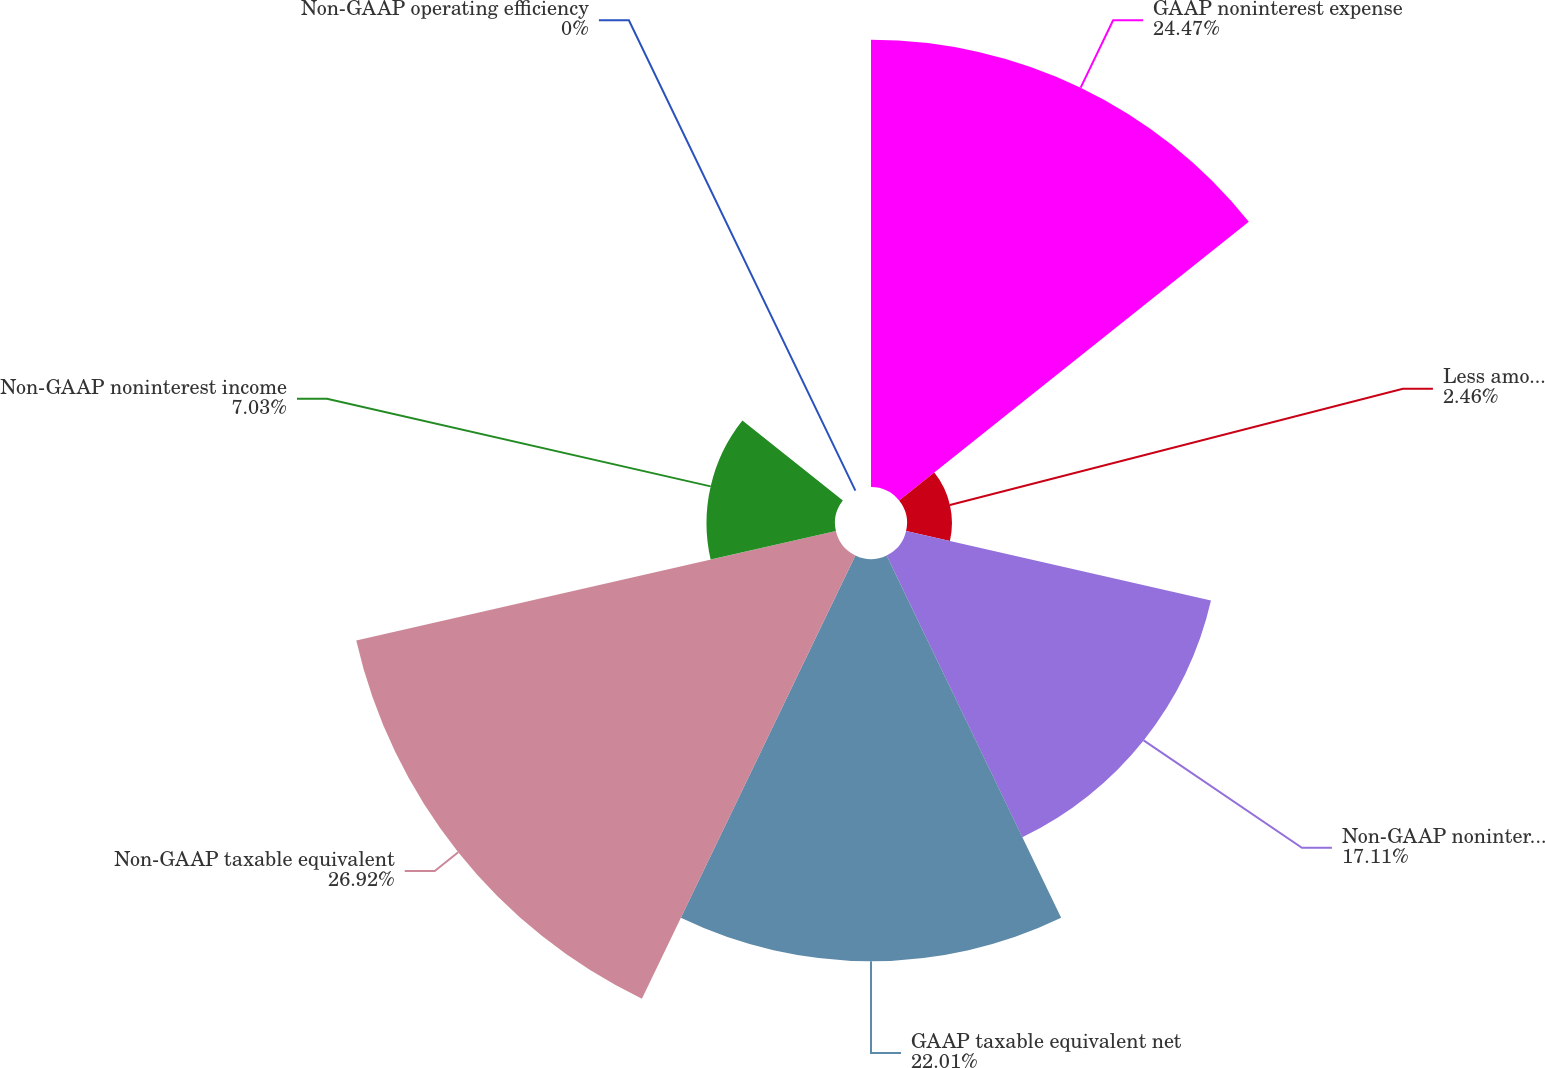Convert chart to OTSL. <chart><loc_0><loc_0><loc_500><loc_500><pie_chart><fcel>GAAP noninterest expense<fcel>Less amounts attributable to<fcel>Non-GAAP noninterest expense<fcel>GAAP taxable equivalent net<fcel>Non-GAAP taxable equivalent<fcel>Non-GAAP noninterest income<fcel>Non-GAAP operating efficiency<nl><fcel>24.47%<fcel>2.46%<fcel>17.11%<fcel>22.01%<fcel>26.92%<fcel>7.03%<fcel>0.0%<nl></chart> 